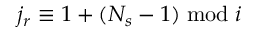<formula> <loc_0><loc_0><loc_500><loc_500>j _ { r } \equiv 1 + ( N _ { s } - 1 ) \bmod i</formula> 